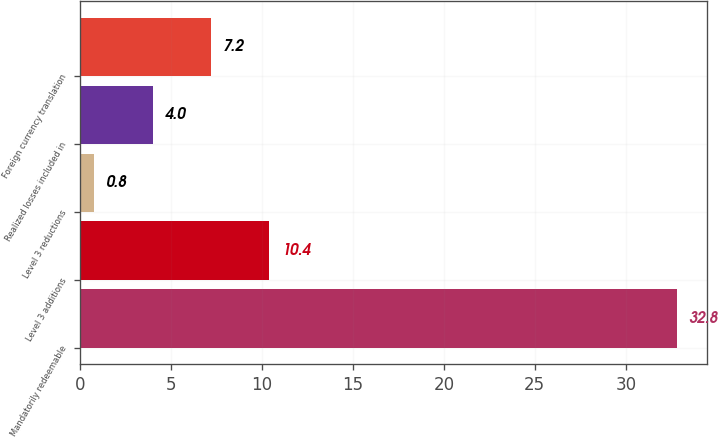Convert chart. <chart><loc_0><loc_0><loc_500><loc_500><bar_chart><fcel>Mandatorily redeemable<fcel>Level 3 additions<fcel>Level 3 reductions<fcel>Realized losses included in<fcel>Foreign currency translation<nl><fcel>32.8<fcel>10.4<fcel>0.8<fcel>4<fcel>7.2<nl></chart> 